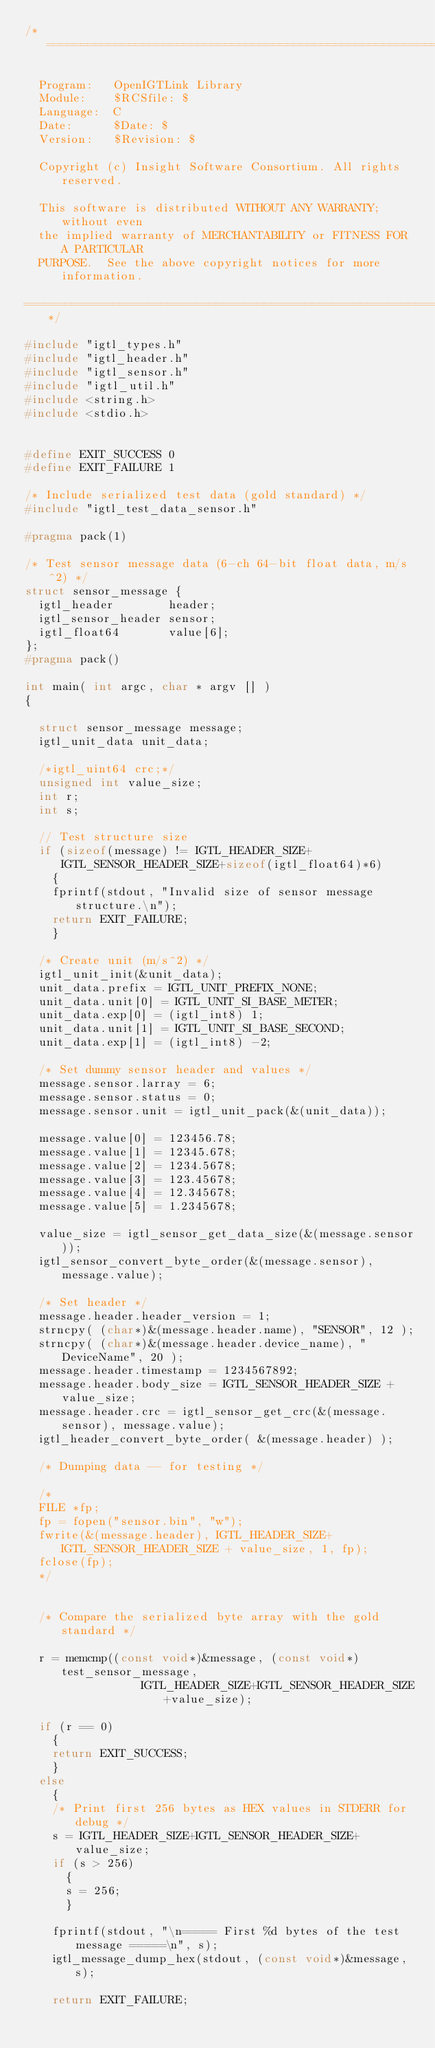Convert code to text. <code><loc_0><loc_0><loc_500><loc_500><_C_>/*=========================================================================

  Program:   OpenIGTLink Library
  Module:    $RCSfile: $
  Language:  C
  Date:      $Date: $
  Version:   $Revision: $

  Copyright (c) Insight Software Consortium. All rights reserved.

  This software is distributed WITHOUT ANY WARRANTY; without even
  the implied warranty of MERCHANTABILITY or FITNESS FOR A PARTICULAR
  PURPOSE.  See the above copyright notices for more information.

=========================================================================*/

#include "igtl_types.h"
#include "igtl_header.h"
#include "igtl_sensor.h"
#include "igtl_util.h"
#include <string.h>
#include <stdio.h>


#define EXIT_SUCCESS 0
#define EXIT_FAILURE 1

/* Include serialized test data (gold standard) */
#include "igtl_test_data_sensor.h"

#pragma pack(1)

/* Test sensor message data (6-ch 64-bit float data, m/s^2) */
struct sensor_message {
  igtl_header        header;
  igtl_sensor_header sensor;
  igtl_float64       value[6];
};
#pragma pack()

int main( int argc, char * argv [] )
{

  struct sensor_message message;
  igtl_unit_data unit_data;

  /*igtl_uint64 crc;*/
  unsigned int value_size;
  int r;
  int s;

  // Test structure size
  if (sizeof(message) != IGTL_HEADER_SIZE+IGTL_SENSOR_HEADER_SIZE+sizeof(igtl_float64)*6)
    {
    fprintf(stdout, "Invalid size of sensor message structure.\n");
    return EXIT_FAILURE;
    }

  /* Create unit (m/s^2) */
  igtl_unit_init(&unit_data);
  unit_data.prefix = IGTL_UNIT_PREFIX_NONE;
  unit_data.unit[0] = IGTL_UNIT_SI_BASE_METER;
  unit_data.exp[0] = (igtl_int8) 1;
  unit_data.unit[1] = IGTL_UNIT_SI_BASE_SECOND;
  unit_data.exp[1] = (igtl_int8) -2;

  /* Set dummy sensor header and values */
  message.sensor.larray = 6;
  message.sensor.status = 0;
  message.sensor.unit = igtl_unit_pack(&(unit_data));
  
  message.value[0] = 123456.78;
  message.value[1] = 12345.678;
  message.value[2] = 1234.5678;
  message.value[3] = 123.45678;
  message.value[4] = 12.345678;
  message.value[5] = 1.2345678;

  value_size = igtl_sensor_get_data_size(&(message.sensor));
  igtl_sensor_convert_byte_order(&(message.sensor), message.value);

  /* Set header */
  message.header.header_version = 1;
  strncpy( (char*)&(message.header.name), "SENSOR", 12 );
  strncpy( (char*)&(message.header.device_name), "DeviceName", 20 );
  message.header.timestamp = 1234567892;
  message.header.body_size = IGTL_SENSOR_HEADER_SIZE + value_size;
  message.header.crc = igtl_sensor_get_crc(&(message.sensor), message.value);
  igtl_header_convert_byte_order( &(message.header) );

  /* Dumping data -- for testing */

  /*
  FILE *fp;
  fp = fopen("sensor.bin", "w");
  fwrite(&(message.header), IGTL_HEADER_SIZE+IGTL_SENSOR_HEADER_SIZE + value_size, 1, fp);
  fclose(fp);
  */


  /* Compare the serialized byte array with the gold standard */ 

  r = memcmp((const void*)&message, (const void*)test_sensor_message,
                 IGTL_HEADER_SIZE+IGTL_SENSOR_HEADER_SIZE+value_size);

  if (r == 0)
    {
    return EXIT_SUCCESS;
    }
  else
    {
    /* Print first 256 bytes as HEX values in STDERR for debug */
    s = IGTL_HEADER_SIZE+IGTL_SENSOR_HEADER_SIZE+value_size;
    if (s > 256)
      {
      s = 256;
      }

    fprintf(stdout, "\n===== First %d bytes of the test message =====\n", s);
    igtl_message_dump_hex(stdout, (const void*)&message, s);

    return EXIT_FAILURE;</code> 